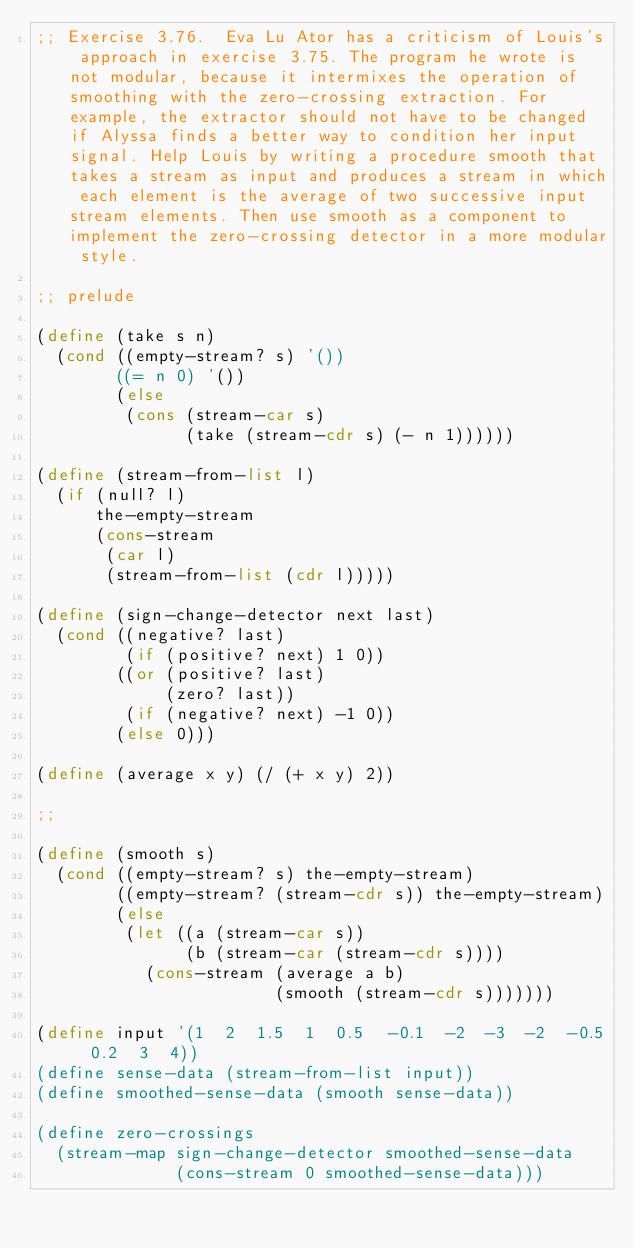<code> <loc_0><loc_0><loc_500><loc_500><_Scheme_>;; Exercise 3.76.  Eva Lu Ator has a criticism of Louis's approach in exercise 3.75. The program he wrote is not modular, because it intermixes the operation of smoothing with the zero-crossing extraction. For example, the extractor should not have to be changed if Alyssa finds a better way to condition her input signal. Help Louis by writing a procedure smooth that takes a stream as input and produces a stream in which each element is the average of two successive input stream elements. Then use smooth as a component to implement the zero-crossing detector in a more modular style.

;; prelude

(define (take s n)
  (cond ((empty-stream? s) '())
        ((= n 0) '())
        (else
         (cons (stream-car s)
               (take (stream-cdr s) (- n 1))))))

(define (stream-from-list l)
  (if (null? l)
      the-empty-stream
      (cons-stream
       (car l)
       (stream-from-list (cdr l)))))

(define (sign-change-detector next last)
  (cond ((negative? last)
         (if (positive? next) 1 0))
        ((or (positive? last)
             (zero? last))
         (if (negative? next) -1 0))
        (else 0)))

(define (average x y) (/ (+ x y) 2))

;;

(define (smooth s)
  (cond ((empty-stream? s) the-empty-stream)
        ((empty-stream? (stream-cdr s)) the-empty-stream)
        (else
         (let ((a (stream-car s))
               (b (stream-car (stream-cdr s))))
           (cons-stream (average a b)
                        (smooth (stream-cdr s)))))))

(define input '(1  2  1.5  1  0.5  -0.1  -2  -3  -2  -0.5  0.2  3  4))
(define sense-data (stream-from-list input))
(define smoothed-sense-data (smooth sense-data))

(define zero-crossings
  (stream-map sign-change-detector smoothed-sense-data
              (cons-stream 0 smoothed-sense-data)))
</code> 